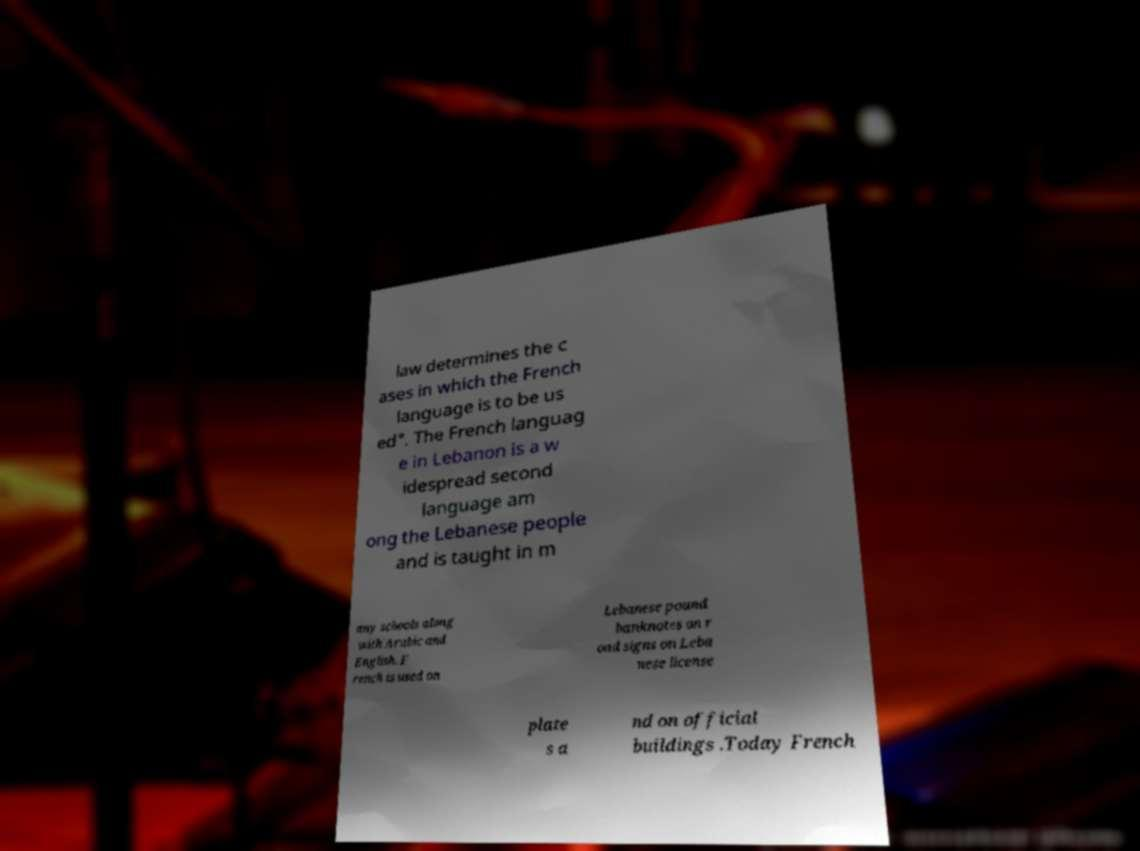What messages or text are displayed in this image? I need them in a readable, typed format. law determines the c ases in which the French language is to be us ed". The French languag e in Lebanon is a w idespread second language am ong the Lebanese people and is taught in m any schools along with Arabic and English. F rench is used on Lebanese pound banknotes on r oad signs on Leba nese license plate s a nd on official buildings .Today French 